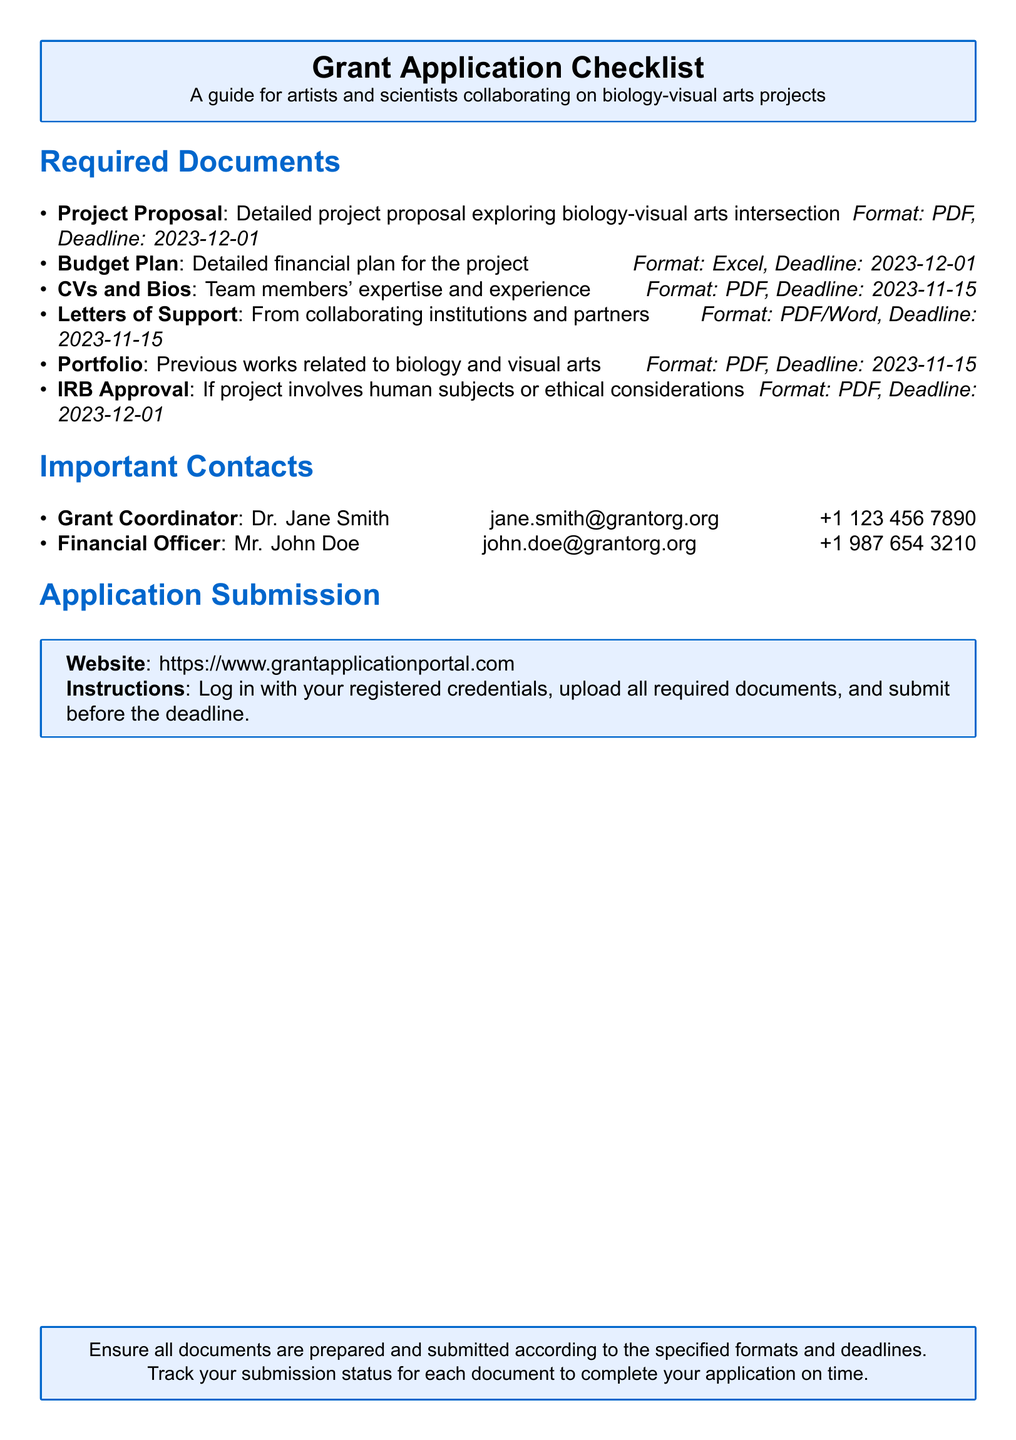What is the deadline for the Project Proposal? The deadline for the Project Proposal is stated in the document as 2023-12-01.
Answer: 2023-12-01 Who is the Grant Coordinator? The document lists Dr. Jane Smith as the Grant Coordinator for the grant application.
Answer: Dr. Jane Smith What format should the Budget Plan be submitted in? The document specifies that the Budget Plan should be submitted in Excel format.
Answer: Excel How many letters of support are required? The document does not specify a particular number, but it states the requirement for letters of support.
Answer: Not specified What is the deadline for submitting CVs and Bios? The document indicates that the deadline for submitting CVs and Bios is 2023-11-15.
Answer: 2023-11-15 Is IRB Approval needed for projects involving human subjects? The document mentions that IRB Approval is needed if the project involves human subjects or ethical considerations.
Answer: Yes What is the website for application submission? The website for application submission is clearly stated in the document as https://www.grantapplicationportal.com.
Answer: https://www.grantapplicationportal.com What commonality do the deadlines for CVs, Letters of Support, and Portfolios share? All three deadlines are on the same date, which is 2023-11-15.
Answer: 2023-11-15 What should be checked before submitting the application? The document advises to ensure all documents are prepared and submitted according to the specified formats and deadlines.
Answer: Document preparation and deadlines 